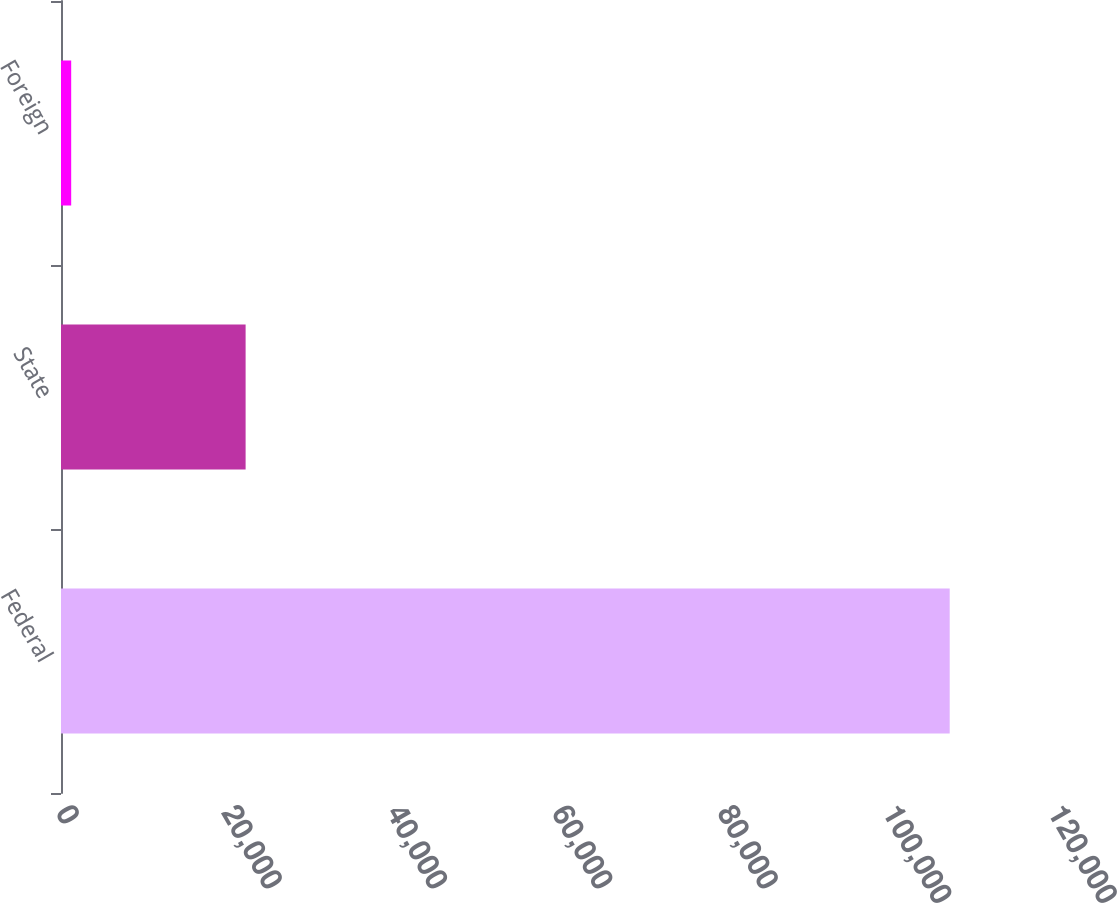Convert chart to OTSL. <chart><loc_0><loc_0><loc_500><loc_500><bar_chart><fcel>Federal<fcel>State<fcel>Foreign<nl><fcel>107503<fcel>22332<fcel>1233<nl></chart> 